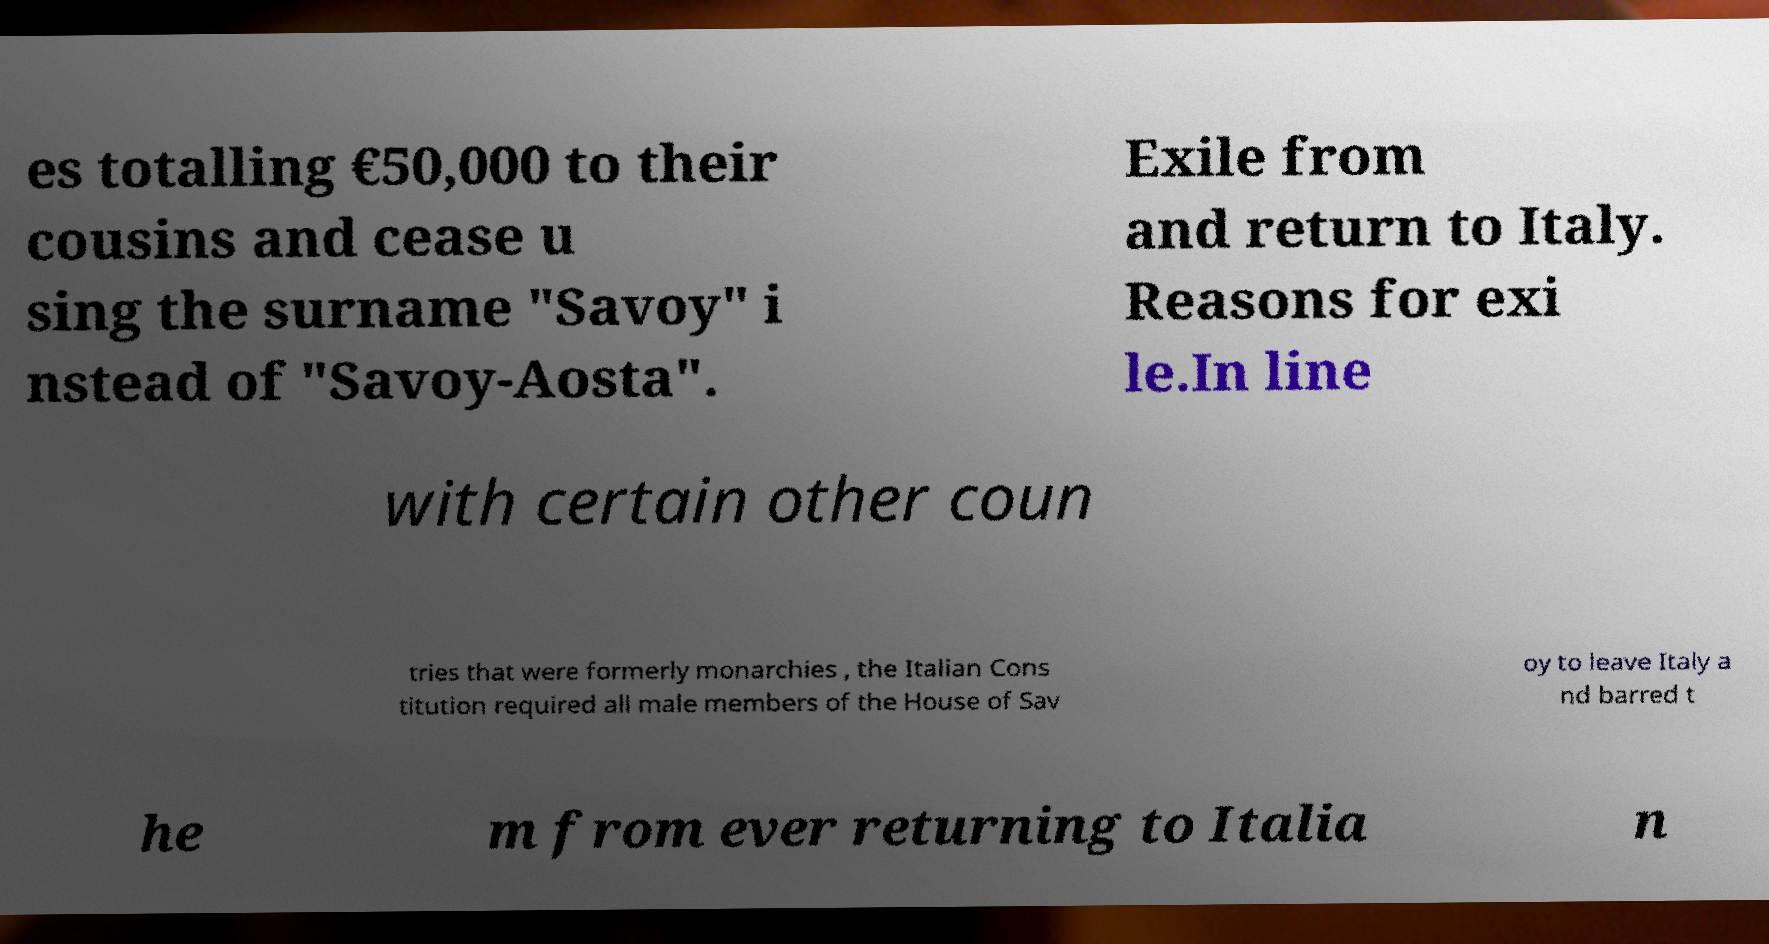Please read and relay the text visible in this image. What does it say? es totalling €50,000 to their cousins and cease u sing the surname "Savoy" i nstead of "Savoy-Aosta". Exile from and return to Italy. Reasons for exi le.In line with certain other coun tries that were formerly monarchies , the Italian Cons titution required all male members of the House of Sav oy to leave Italy a nd barred t he m from ever returning to Italia n 